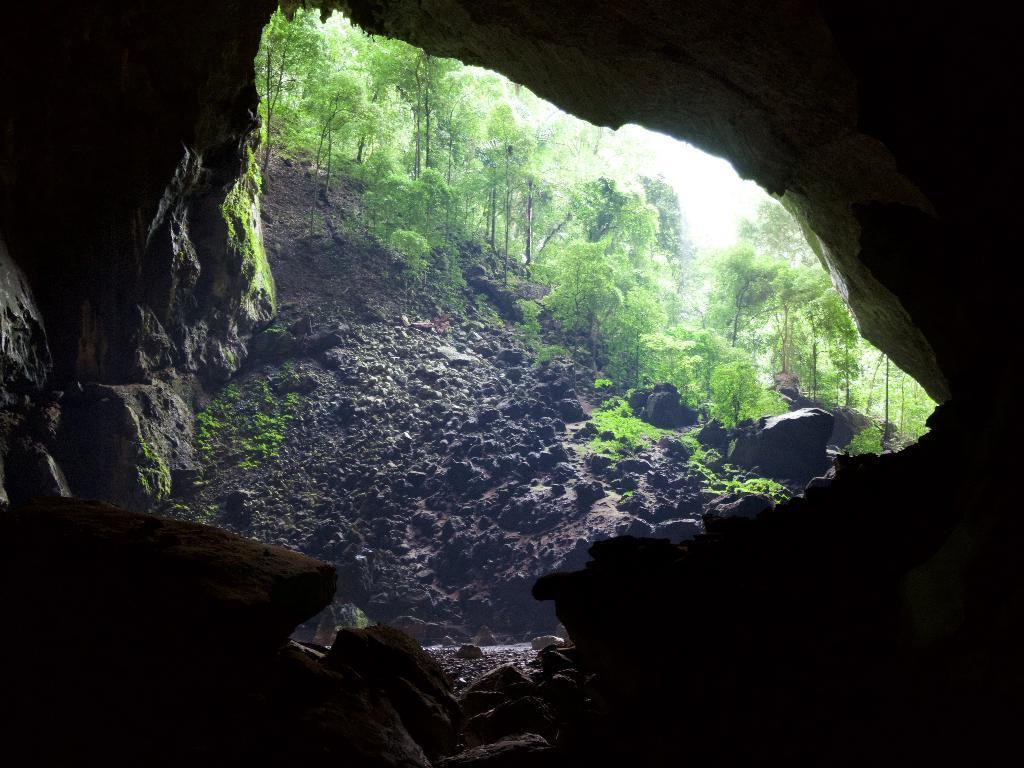Describe this image in one or two sentences. In the picture we can see from rock cave, outside we can see some rocks with path and plants and trees. 